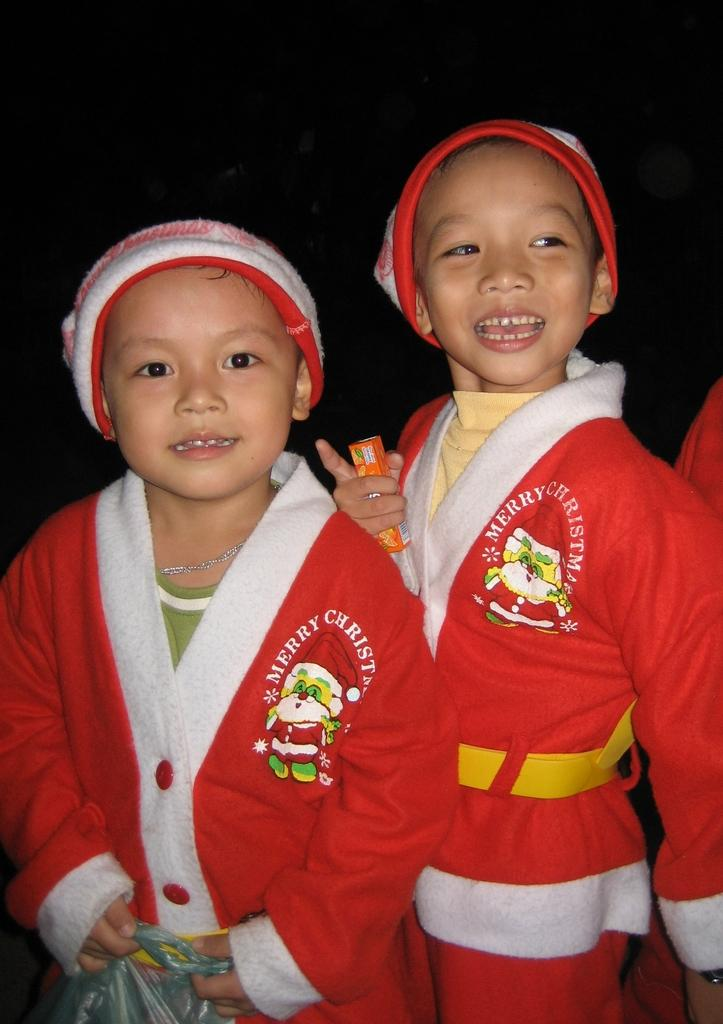<image>
Create a compact narrative representing the image presented. Two children are wearing Christmas attire with MERRY CHRISTMAS over the heart. 